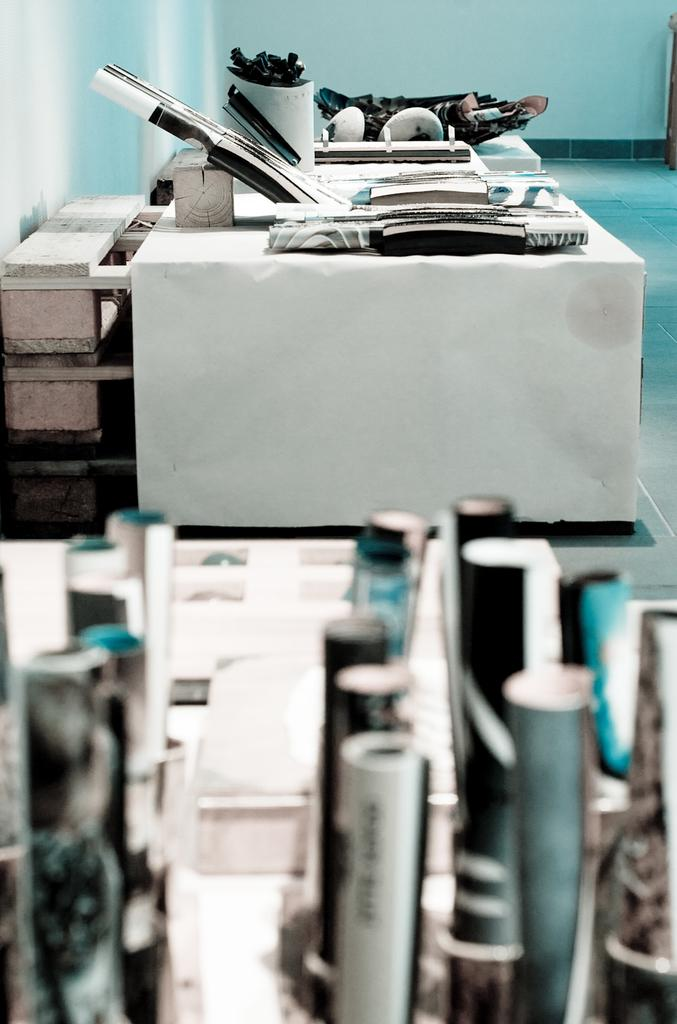What is located in the center of the image? There are tables in the center of the image. What is placed on the tables? Papers and boxes are placed on the tables. Are there any other items on the tables besides papers and boxes? Yes, there are other unspecified items on the tables. What can be seen in the background of the image? There is a wall in the background of the image. How does the growth of the plants affect the bridge in the image? There are no plants or bridges present in the image, so this question cannot be answered. 